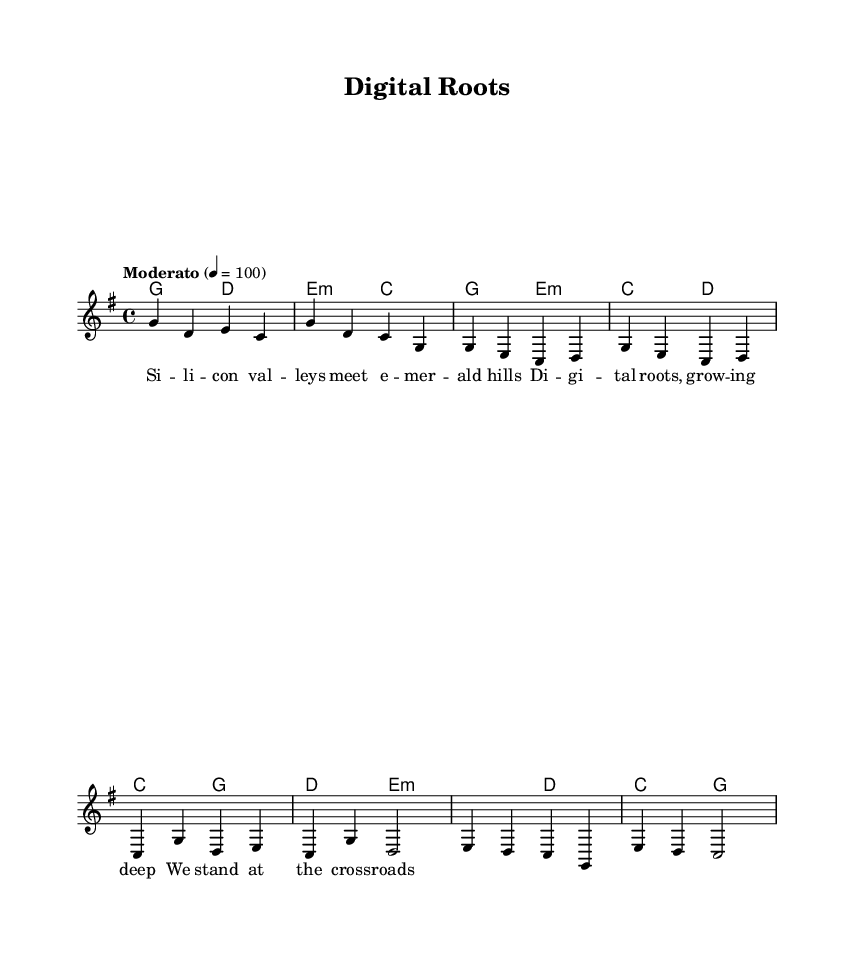What is the key signature of this music? The key signature is G major, which features one sharp (F sharp). This can be identified at the beginning of the staff, where the sharps are displayed.
Answer: G major What is the time signature of this music? The time signature is 4/4, which allows for four beats per measure and a quarter note receives one beat. This is indicated at the beginning of the sheet music following the clef and key signature.
Answer: 4/4 What is the tempo marking for this piece? The tempo marking is Moderato, which indicates a moderately paced piece. It is written above the staff and also indicates that the tempo is set at a metronome marking of 100 beats per minute.
Answer: Moderato Which section contains the lyrics "Digital roots, growing deep"? The lyrics "Digital roots, growing deep" are located in the Chorus section of the song. This can be inferred from the alignment of the lyrics under the musical notes, typically after the verse and before the bridge.
Answer: Chorus How many measures are there in the introduction? There are two measures in the introduction, as indicated by the placement of the bars in the sheet music. Each measure contains a set of notes, visually demarcated by the vertical lines.
Answer: 2 What chord corresponds with the lyrics "We stand at the crossroads"? The chord corresponding to the lyrics "We stand at the crossroads" is E minor. This can be determined by looking at the chord symbols above the lyrics during the bridge section.
Answer: E minor Which musical element signifies the transition to a different section in the song? The bridge serves as the musical element that signifies a transition to a different section in the song. It's typically distinguished by a change in melody and harmony patterns from the preceding verse or chorus.
Answer: Bridge 